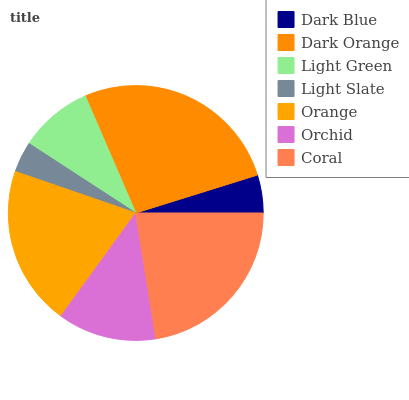Is Light Slate the minimum?
Answer yes or no. Yes. Is Dark Orange the maximum?
Answer yes or no. Yes. Is Light Green the minimum?
Answer yes or no. No. Is Light Green the maximum?
Answer yes or no. No. Is Dark Orange greater than Light Green?
Answer yes or no. Yes. Is Light Green less than Dark Orange?
Answer yes or no. Yes. Is Light Green greater than Dark Orange?
Answer yes or no. No. Is Dark Orange less than Light Green?
Answer yes or no. No. Is Orchid the high median?
Answer yes or no. Yes. Is Orchid the low median?
Answer yes or no. Yes. Is Orange the high median?
Answer yes or no. No. Is Coral the low median?
Answer yes or no. No. 